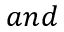<formula> <loc_0><loc_0><loc_500><loc_500>a n d</formula> 